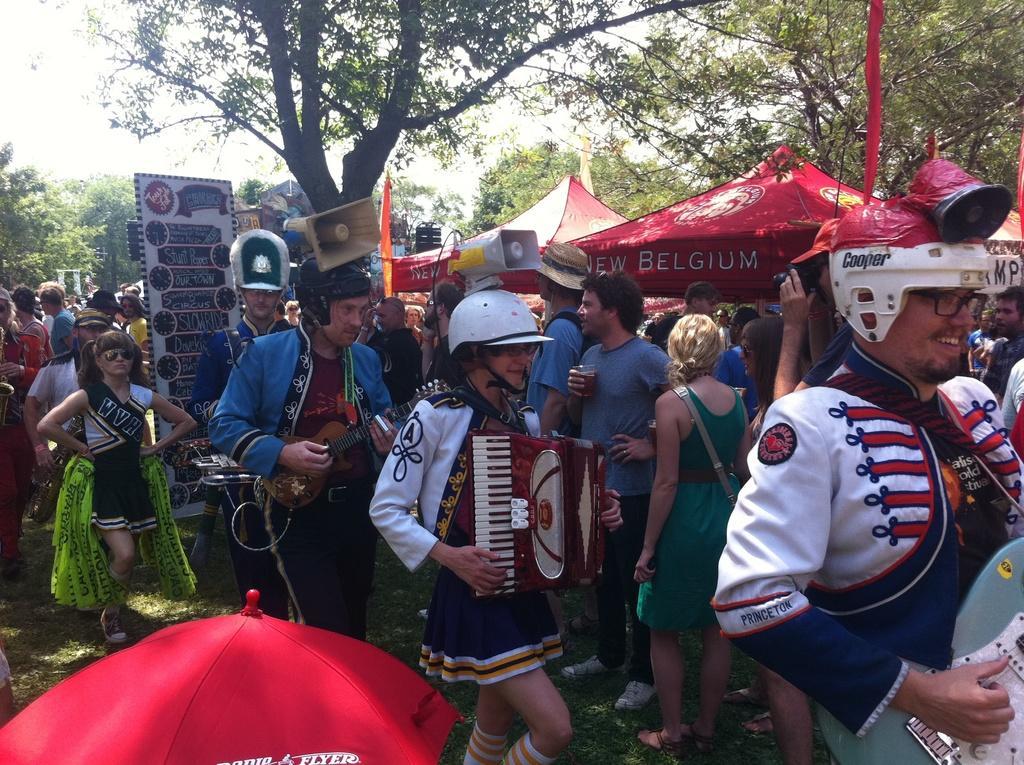Describe this image in one or two sentences. There are people and these three people playing musical instruments. We can see speakers, board, umbrella, tents and grass. In the background we can see trees and sky. 